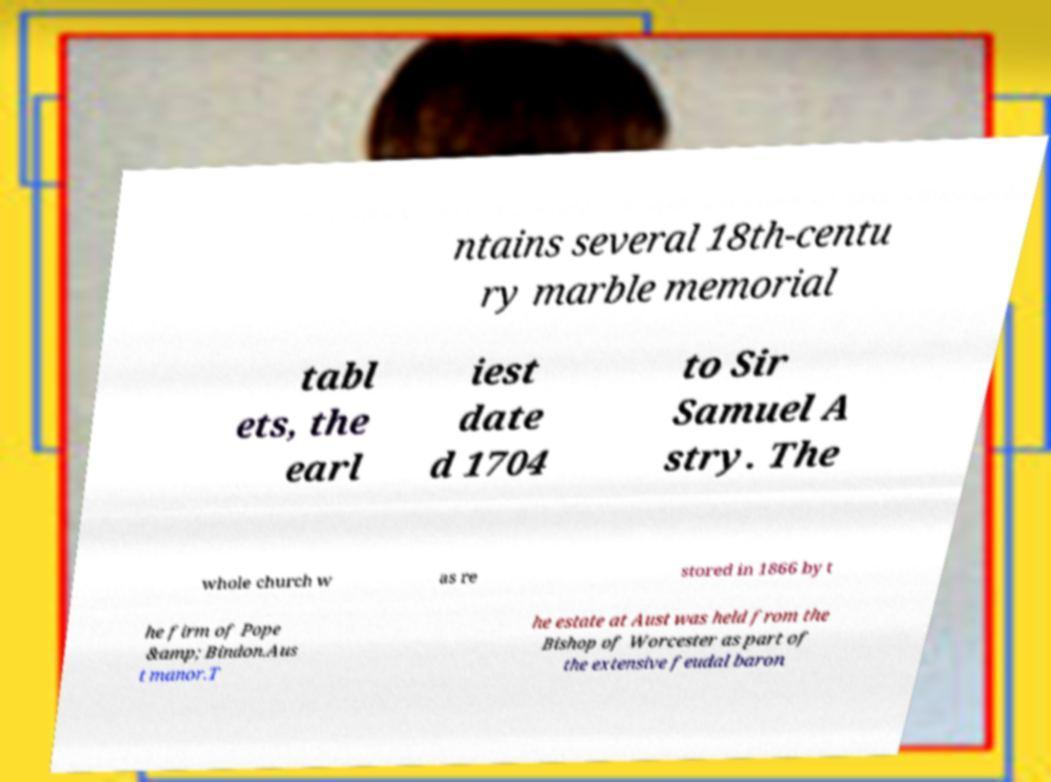Can you accurately transcribe the text from the provided image for me? ntains several 18th-centu ry marble memorial tabl ets, the earl iest date d 1704 to Sir Samuel A stry. The whole church w as re stored in 1866 by t he firm of Pope &amp; Bindon.Aus t manor.T he estate at Aust was held from the Bishop of Worcester as part of the extensive feudal baron 